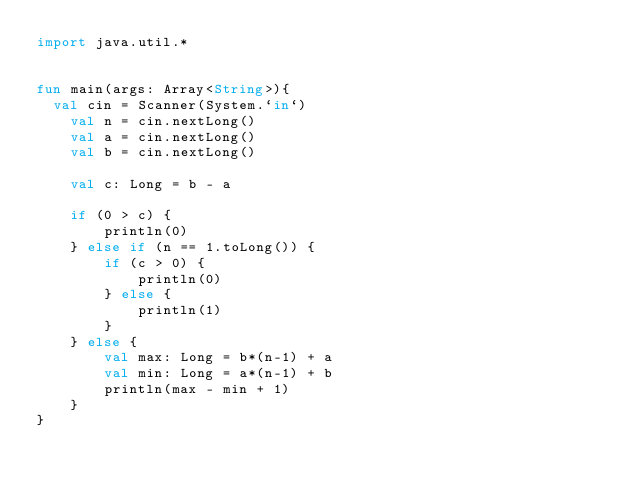Convert code to text. <code><loc_0><loc_0><loc_500><loc_500><_Kotlin_>import java.util.*


fun main(args: Array<String>){
	val cin = Scanner(System.`in`)
    val n = cin.nextLong()
    val a = cin.nextLong()
    val b = cin.nextLong()

    val c: Long = b - a

    if (0 > c) {
        println(0)
    } else if (n == 1.toLong()) {
        if (c > 0) {
            println(0)
        } else {
            println(1)
        }
    } else {
        val max: Long = b*(n-1) + a
        val min: Long = a*(n-1) + b
        println(max - min + 1)
    }
}</code> 